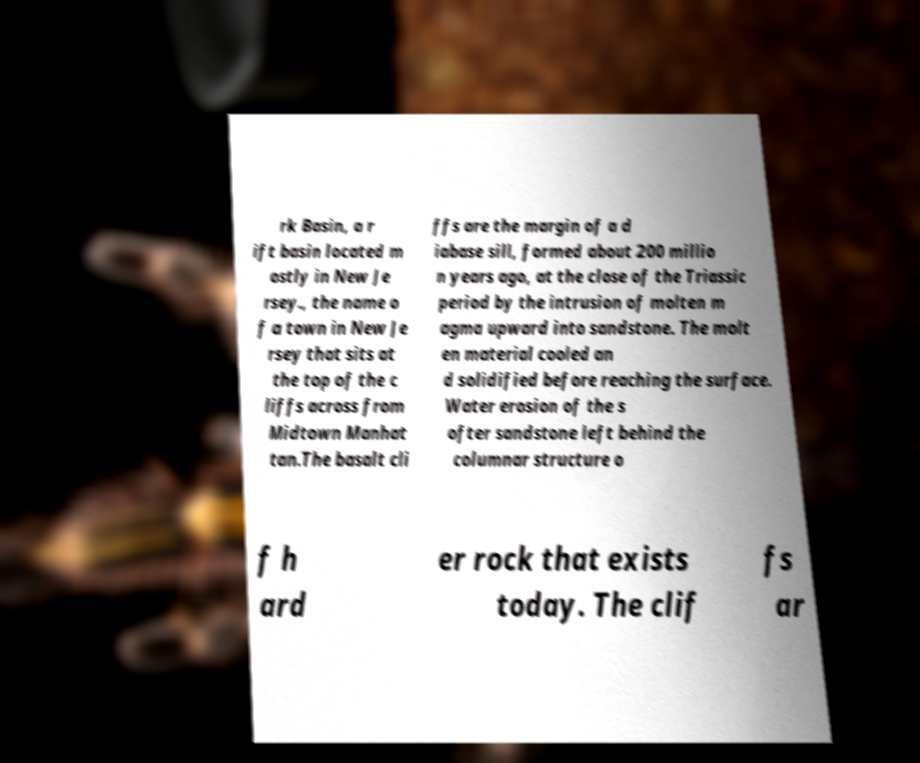Can you accurately transcribe the text from the provided image for me? rk Basin, a r ift basin located m ostly in New Je rsey., the name o f a town in New Je rsey that sits at the top of the c liffs across from Midtown Manhat tan.The basalt cli ffs are the margin of a d iabase sill, formed about 200 millio n years ago, at the close of the Triassic period by the intrusion of molten m agma upward into sandstone. The molt en material cooled an d solidified before reaching the surface. Water erosion of the s ofter sandstone left behind the columnar structure o f h ard er rock that exists today. The clif fs ar 